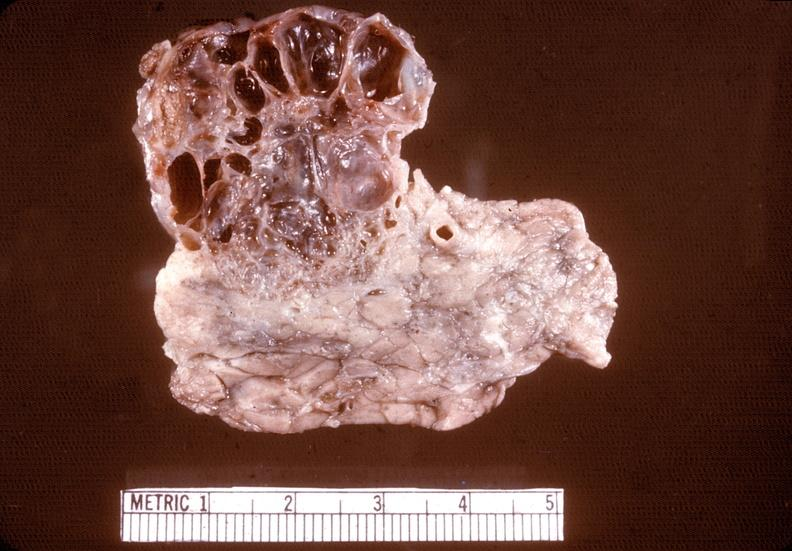does this image show cystadenoma?
Answer the question using a single word or phrase. Yes 